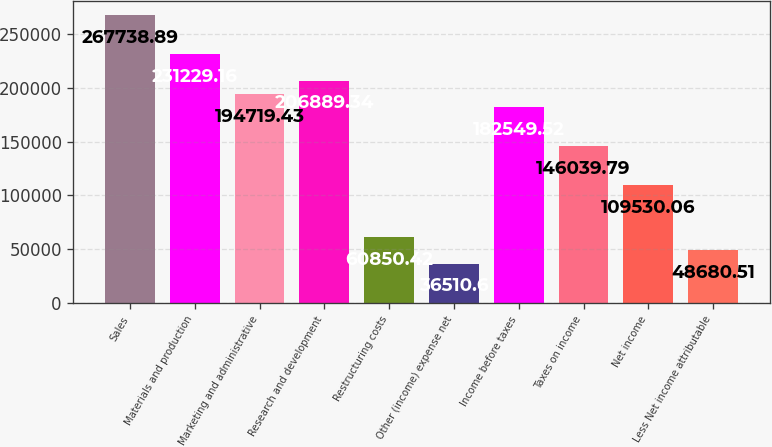Convert chart to OTSL. <chart><loc_0><loc_0><loc_500><loc_500><bar_chart><fcel>Sales<fcel>Materials and production<fcel>Marketing and administrative<fcel>Research and development<fcel>Restructuring costs<fcel>Other (income) expense net<fcel>Income before taxes<fcel>Taxes on income<fcel>Net income<fcel>Less Net income attributable<nl><fcel>267739<fcel>231229<fcel>194719<fcel>206889<fcel>60850.4<fcel>36510.6<fcel>182550<fcel>146040<fcel>109530<fcel>48680.5<nl></chart> 